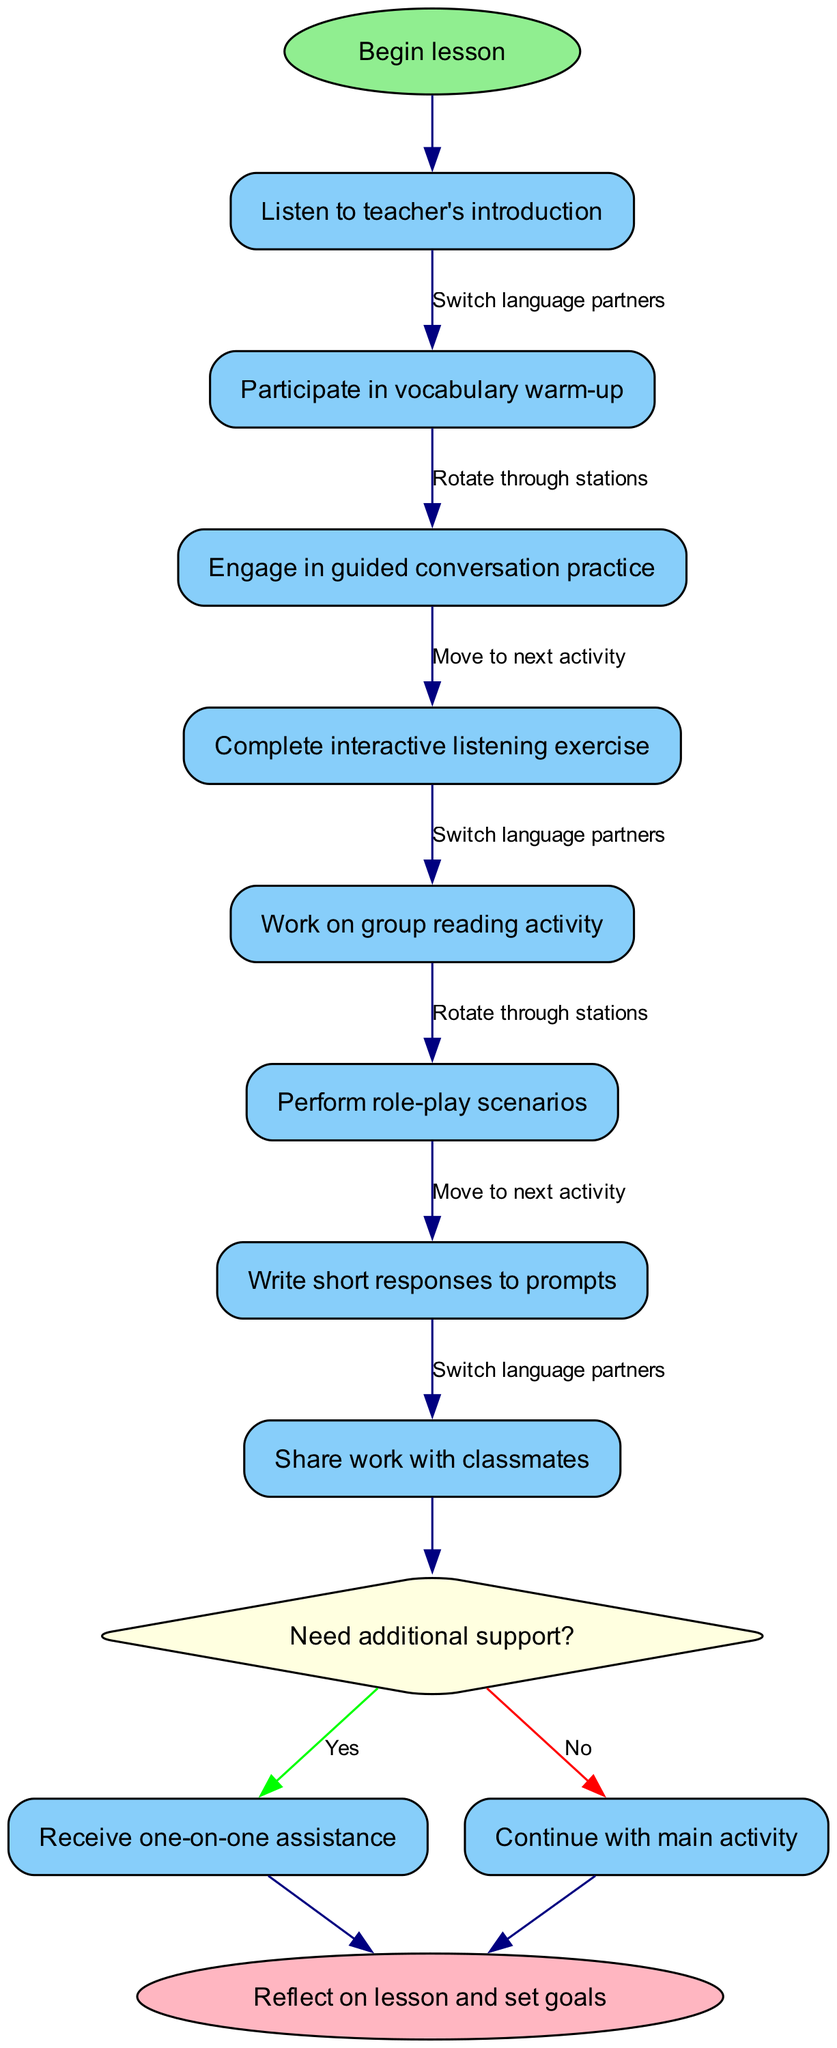What is the initial node of the diagram? The initial node represents the starting point of the flowchart. In this case, it is labeled "Begin lesson."
Answer: Begin lesson How many activities are listed in the diagram? By counting the activities provided, there are eight unique student activities specified in the diagram that make up the process.
Answer: 8 What is the first activity after the lesson begins? The first activity follows directly from the initial node and is the first listed activity; it is "Listen to teacher's introduction."
Answer: Listen to teacher's introduction What question is asked at the decision node? The decision node prompts the students with a question about their needs, specifically inquiring if they "Need additional support?"
Answer: Need additional support? If a student answers "no" at the decision node, which node do they proceed to next? If they respond "no," they continue with the main activity, which in this case leads them again to the final node after completing their current activity.
Answer: Reflect on lesson and set goals How many transitions are indicated in the activities? The number of transitions is determined by how many different status shifts are labeled between the activities. According to the data, there are three unique transitions.
Answer: 3 What type of activity is performed after "Engage in guided conversation practice"? The flow of activities shows that after engaging in guided conversation practice, the next listed activity is "Complete interactive listening exercise."
Answer: Complete interactive listening exercise What happens after a student receives one-on-one assistance? Following one-on-one assistance, they are expected to move back to the main activities, ultimately progressing toward the ending of the lesson, which is the final node.
Answer: Continue with main activity 